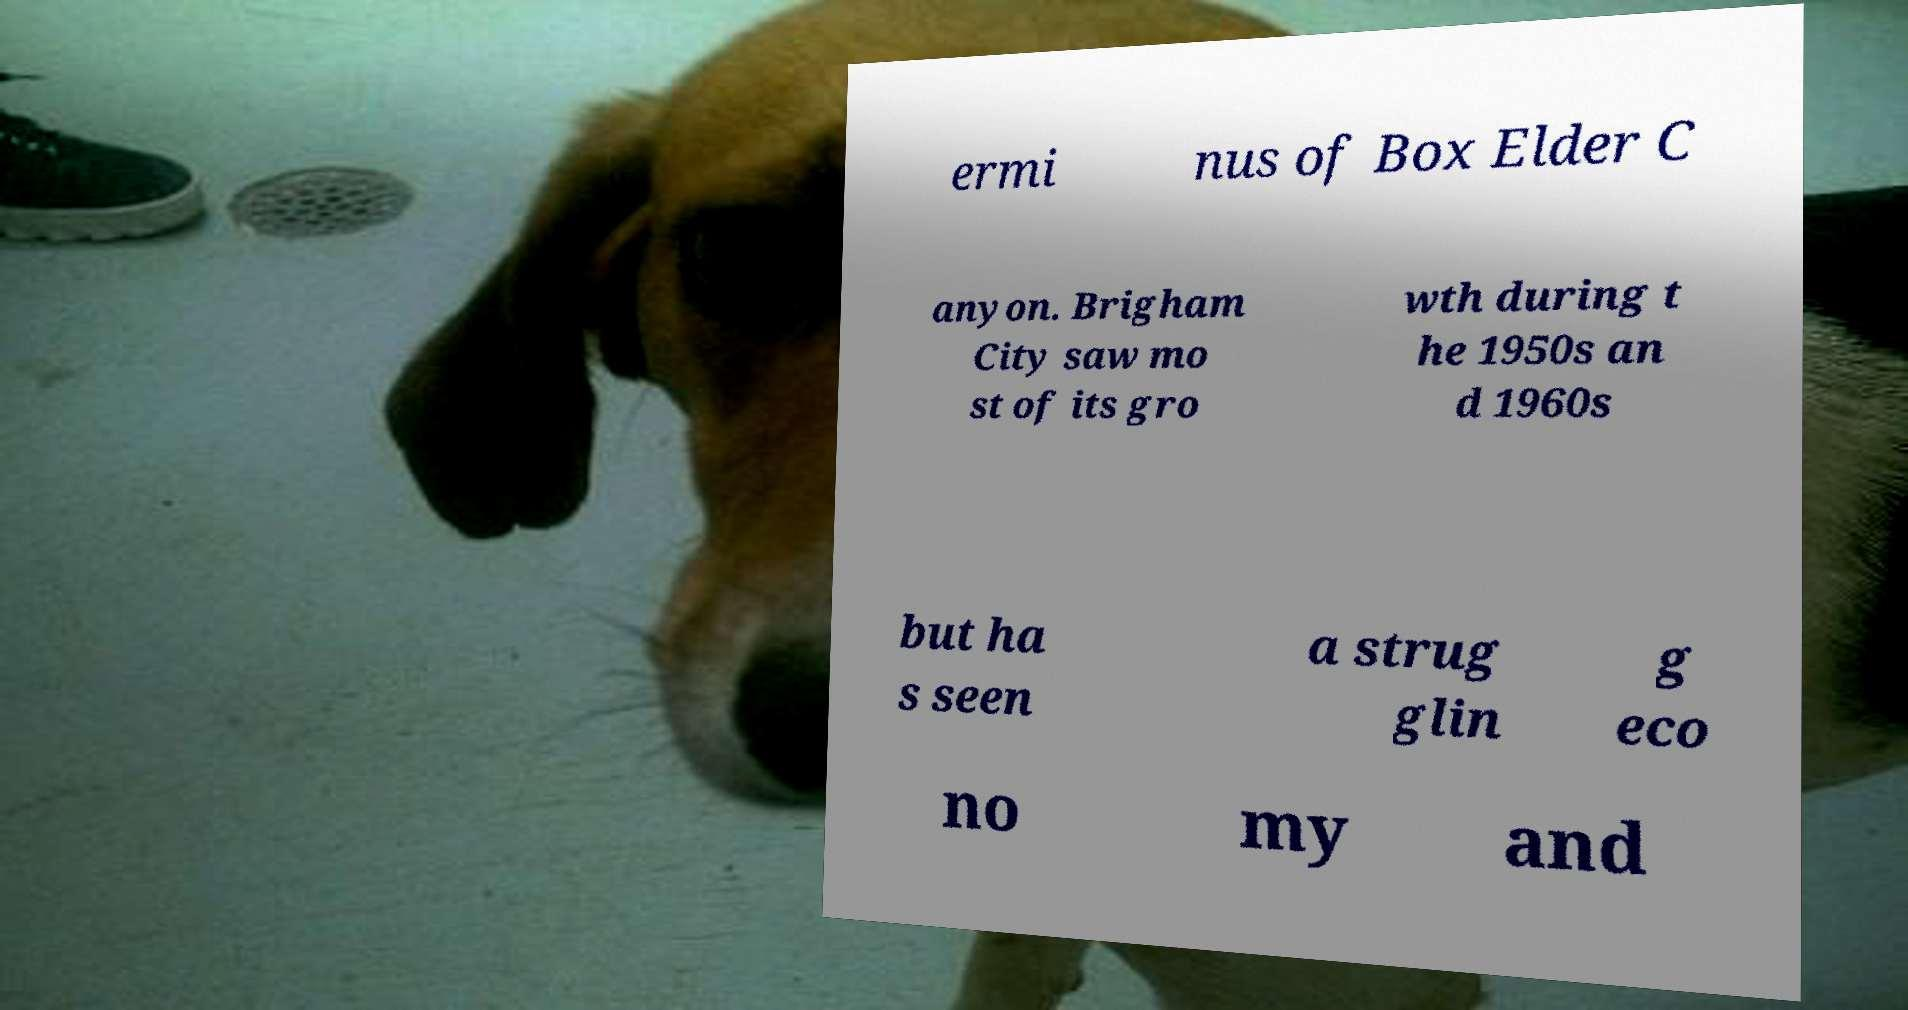Can you accurately transcribe the text from the provided image for me? ermi nus of Box Elder C anyon. Brigham City saw mo st of its gro wth during t he 1950s an d 1960s but ha s seen a strug glin g eco no my and 